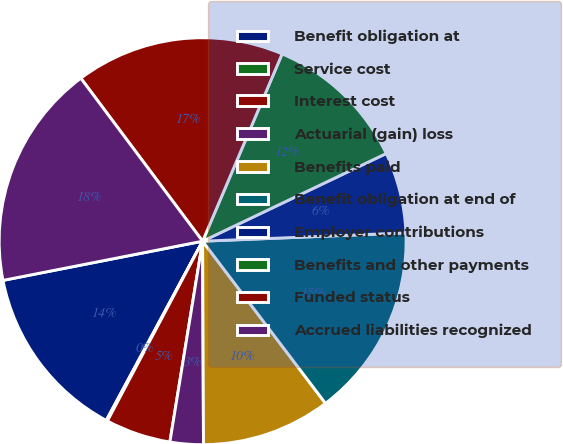Convert chart to OTSL. <chart><loc_0><loc_0><loc_500><loc_500><pie_chart><fcel>Benefit obligation at<fcel>Service cost<fcel>Interest cost<fcel>Actuarial (gain) loss<fcel>Benefits paid<fcel>Benefit obligation at end of<fcel>Employer contributions<fcel>Benefits and other payments<fcel>Funded status<fcel>Accrued liabilities recognized<nl><fcel>14.06%<fcel>0.1%<fcel>5.18%<fcel>2.64%<fcel>10.25%<fcel>15.33%<fcel>6.44%<fcel>11.52%<fcel>16.6%<fcel>17.87%<nl></chart> 